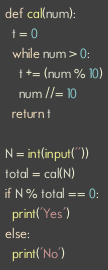<code> <loc_0><loc_0><loc_500><loc_500><_Python_>def cal(num):
  t = 0
  while num > 0:
    t += (num % 10)
    num //= 10
  return t
  
N = int(input(''))
total = cal(N)
if N % total == 0:
  print('Yes')
else:
  print('No')</code> 